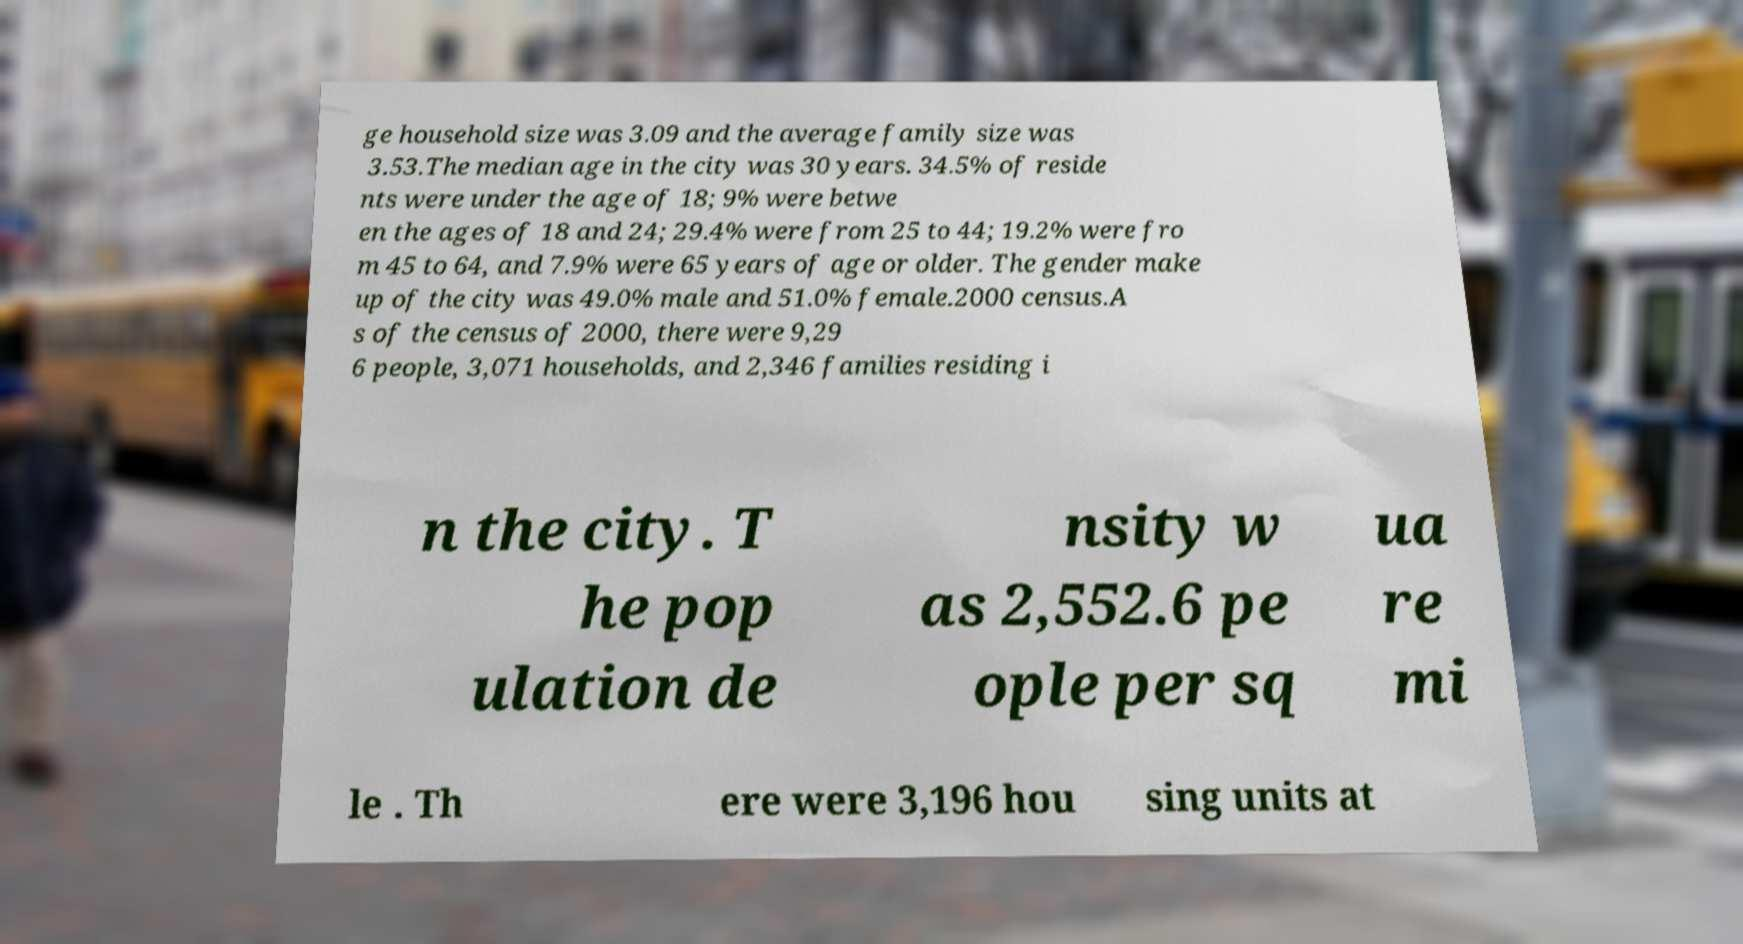What messages or text are displayed in this image? I need them in a readable, typed format. ge household size was 3.09 and the average family size was 3.53.The median age in the city was 30 years. 34.5% of reside nts were under the age of 18; 9% were betwe en the ages of 18 and 24; 29.4% were from 25 to 44; 19.2% were fro m 45 to 64, and 7.9% were 65 years of age or older. The gender make up of the city was 49.0% male and 51.0% female.2000 census.A s of the census of 2000, there were 9,29 6 people, 3,071 households, and 2,346 families residing i n the city. T he pop ulation de nsity w as 2,552.6 pe ople per sq ua re mi le . Th ere were 3,196 hou sing units at 